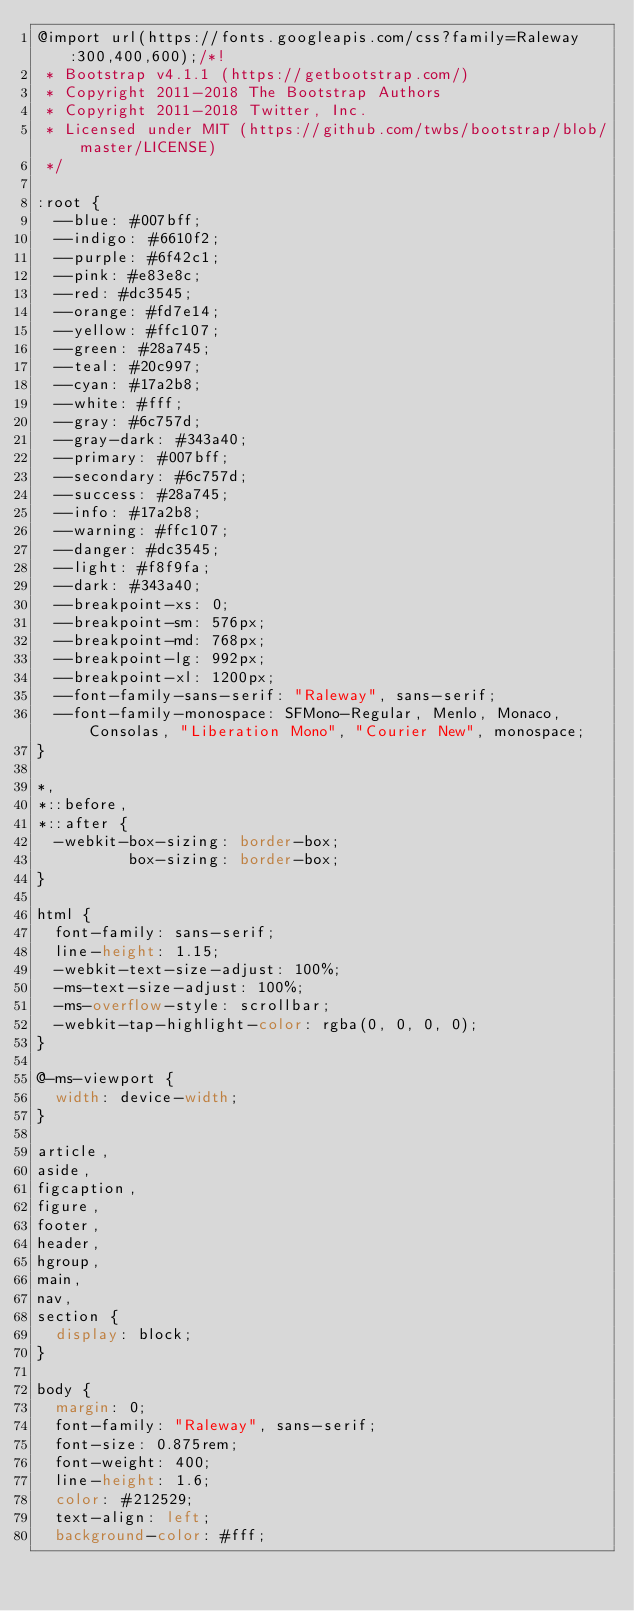<code> <loc_0><loc_0><loc_500><loc_500><_CSS_>@import url(https://fonts.googleapis.com/css?family=Raleway:300,400,600);/*!
 * Bootstrap v4.1.1 (https://getbootstrap.com/)
 * Copyright 2011-2018 The Bootstrap Authors
 * Copyright 2011-2018 Twitter, Inc.
 * Licensed under MIT (https://github.com/twbs/bootstrap/blob/master/LICENSE)
 */

:root {
  --blue: #007bff;
  --indigo: #6610f2;
  --purple: #6f42c1;
  --pink: #e83e8c;
  --red: #dc3545;
  --orange: #fd7e14;
  --yellow: #ffc107;
  --green: #28a745;
  --teal: #20c997;
  --cyan: #17a2b8;
  --white: #fff;
  --gray: #6c757d;
  --gray-dark: #343a40;
  --primary: #007bff;
  --secondary: #6c757d;
  --success: #28a745;
  --info: #17a2b8;
  --warning: #ffc107;
  --danger: #dc3545;
  --light: #f8f9fa;
  --dark: #343a40;
  --breakpoint-xs: 0;
  --breakpoint-sm: 576px;
  --breakpoint-md: 768px;
  --breakpoint-lg: 992px;
  --breakpoint-xl: 1200px;
  --font-family-sans-serif: "Raleway", sans-serif;
  --font-family-monospace: SFMono-Regular, Menlo, Monaco, Consolas, "Liberation Mono", "Courier New", monospace;
}

*,
*::before,
*::after {
  -webkit-box-sizing: border-box;
          box-sizing: border-box;
}

html {
  font-family: sans-serif;
  line-height: 1.15;
  -webkit-text-size-adjust: 100%;
  -ms-text-size-adjust: 100%;
  -ms-overflow-style: scrollbar;
  -webkit-tap-highlight-color: rgba(0, 0, 0, 0);
}

@-ms-viewport {
  width: device-width;
}

article,
aside,
figcaption,
figure,
footer,
header,
hgroup,
main,
nav,
section {
  display: block;
}

body {
  margin: 0;
  font-family: "Raleway", sans-serif;
  font-size: 0.875rem;
  font-weight: 400;
  line-height: 1.6;
  color: #212529;
  text-align: left;
  background-color: #fff;</code> 